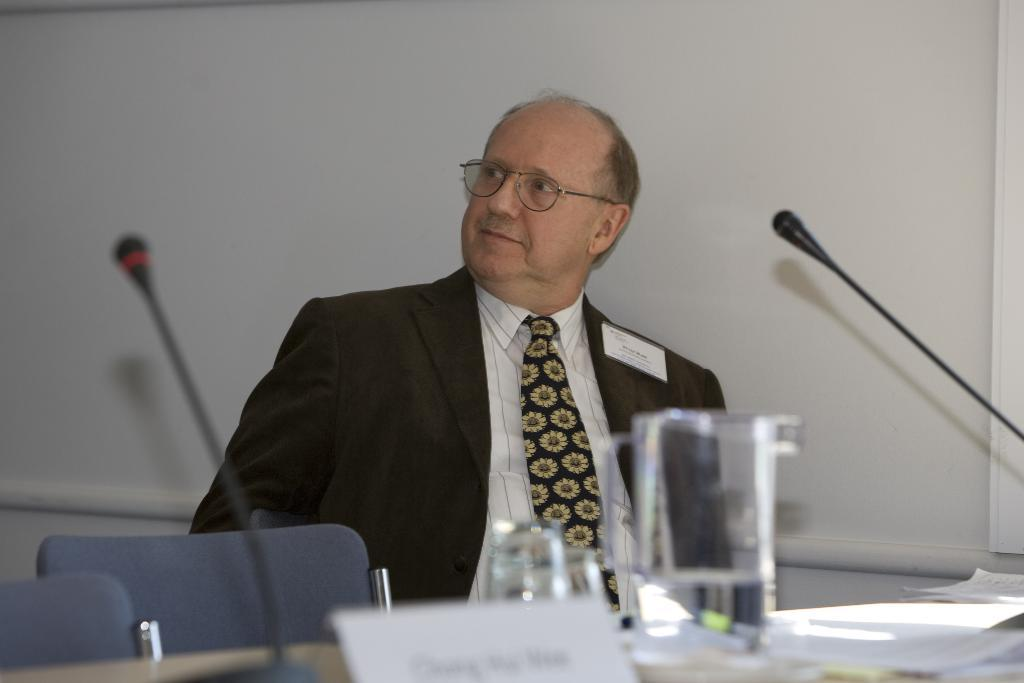What type of clothing is the man wearing on his upper body in the image? The man is wearing a shirt and a coat in the image. What additional accessory is the man wearing with his shirt and coat? The man is also wearing a tie in the image. What type of bean is growing in the man's coat pocket in the image? There is no bean visible in the man's coat pocket in the image. 